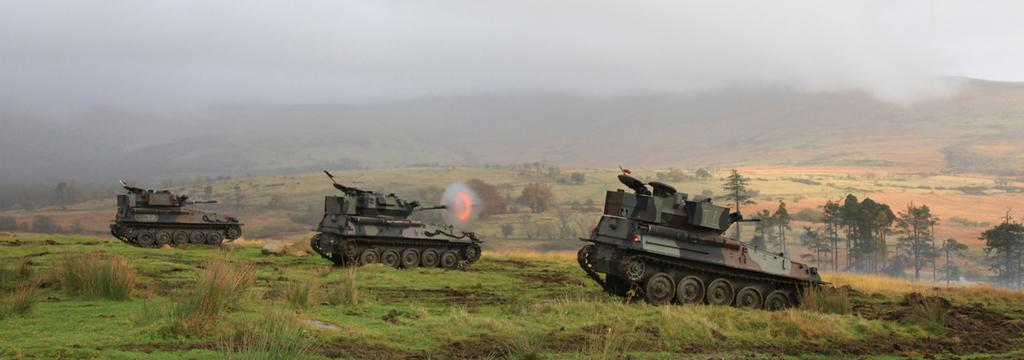What type of vehicles are in the foreground of the image? There are three military tanks in the foreground of the image. Where are the tanks located? The tanks are on the grass. What can be seen in the background of the image? There are mountains, trees, and the sky visible in the background of the image. Which tank is responsible for attracting the most berries in the image? There are no berries present in the image, and therefore no attraction can be observed between the tanks and berries. 